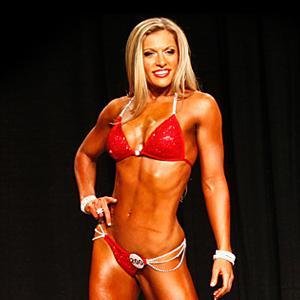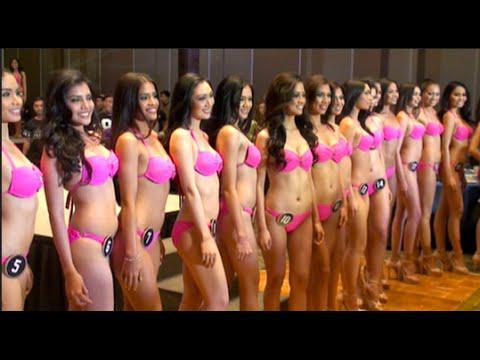The first image is the image on the left, the second image is the image on the right. Analyze the images presented: Is the assertion "A single blonde woman is wearing a bikini in one of the images." valid? Answer yes or no. Yes. The first image is the image on the left, the second image is the image on the right. Considering the images on both sides, is "In at least one image there are at least two identical women in blue bikinis." valid? Answer yes or no. No. 